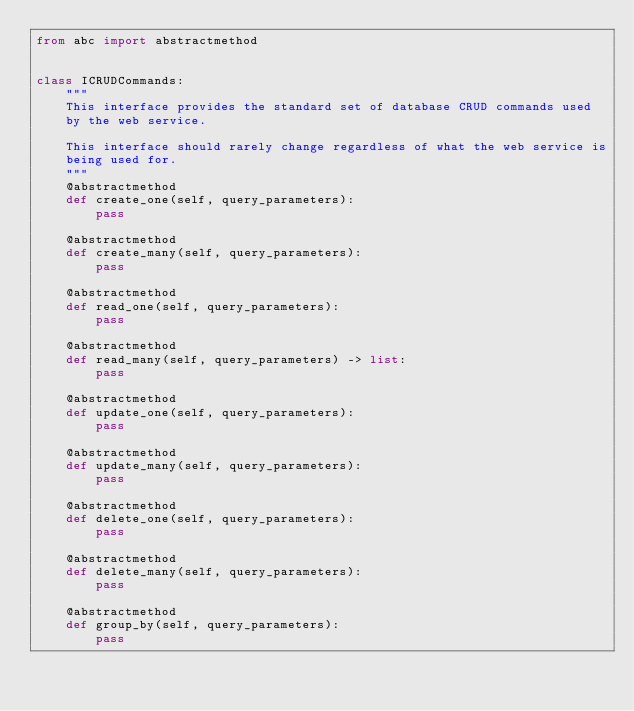Convert code to text. <code><loc_0><loc_0><loc_500><loc_500><_Python_>from abc import abstractmethod


class ICRUDCommands:
    """
    This interface provides the standard set of database CRUD commands used
    by the web service.

    This interface should rarely change regardless of what the web service is
    being used for.
    """
    @abstractmethod
    def create_one(self, query_parameters):
        pass

    @abstractmethod
    def create_many(self, query_parameters):
        pass

    @abstractmethod
    def read_one(self, query_parameters):
        pass

    @abstractmethod
    def read_many(self, query_parameters) -> list:
        pass

    @abstractmethod
    def update_one(self, query_parameters):
        pass

    @abstractmethod
    def update_many(self, query_parameters):
        pass

    @abstractmethod
    def delete_one(self, query_parameters):
        pass

    @abstractmethod
    def delete_many(self, query_parameters):
        pass

    @abstractmethod
    def group_by(self, query_parameters):
        pass</code> 